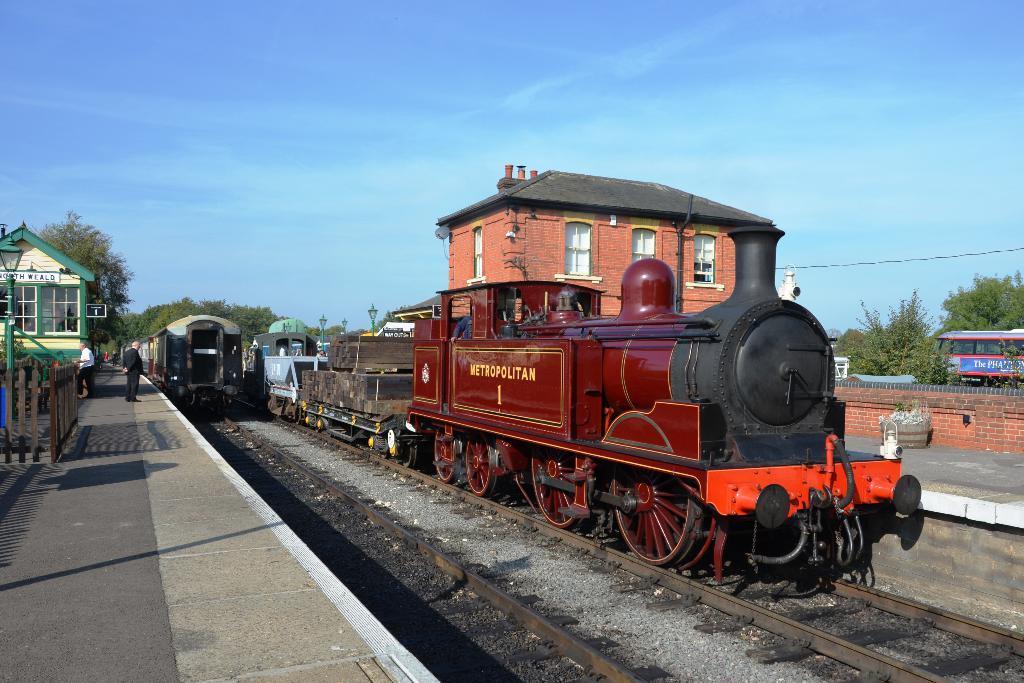Please provide a concise description of this image. In this image there are trains on the railway tracks. On the either sides of the tracks there are platforms. To the left there are people standing on the platform. Behind them there is a railing. In the background there are trees and a house. At the top there is the sky. 